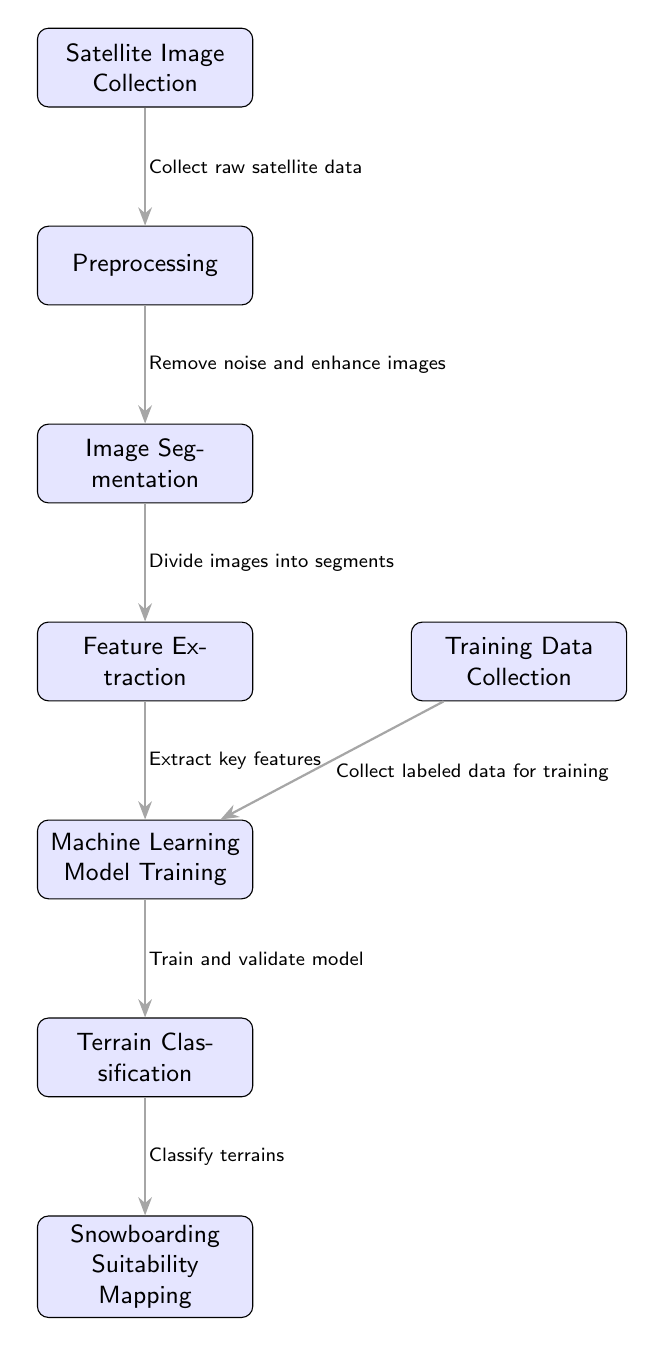What is the first step in the process? The first node in the diagram is labeled "Satellite Image Collection." Therefore, this is the initial step.
Answer: Satellite Image Collection How many nodes are there in total? The diagram includes eight nodes in the workflow, each representing a different step. Counting them gives the total number of nodes.
Answer: Eight What is extracted during the feature extraction step? The edge leading to the "Machine Learning Model Training" node specifies that key features are extracted during this step.
Answer: Key features What connects image segmentation and feature extraction? The edge between the nodes indicates that the segmentation process leads into feature extraction, thus establishing their connection.
Answer: Divide images into segments What follows machine learning model training in the workflow? The next node after "Machine Learning Model Training" is "Terrain Classification," indicating the order of operations.
Answer: Terrain Classification Which node is connected to training data collection? The "Machine Learning Model Training" node is connected to "Training Data Collection," indicating that labeled data is necessary for the training process.
Answer: Machine Learning Model Training How is snowboarding suitability determined? The "Terrain Classification" node is directly linked to "Snowboarding Suitability Mapping," indicating that terrain classification informs the mapping of snowboarding suitability.
Answer: Classify terrains What action is taken during preprocessing? The edge leading to the "Image Segmentation" node specifies that noise is removed and images are enhanced during preprocessing.
Answer: Remove noise and enhance images What is the function of the last node in the diagram? The last node, labeled "Snowboarding Suitability Mapping," indicates that it is where the results of the prior classifications are mapped for suitability analysis.
Answer: Snowboarding Suitability Mapping 